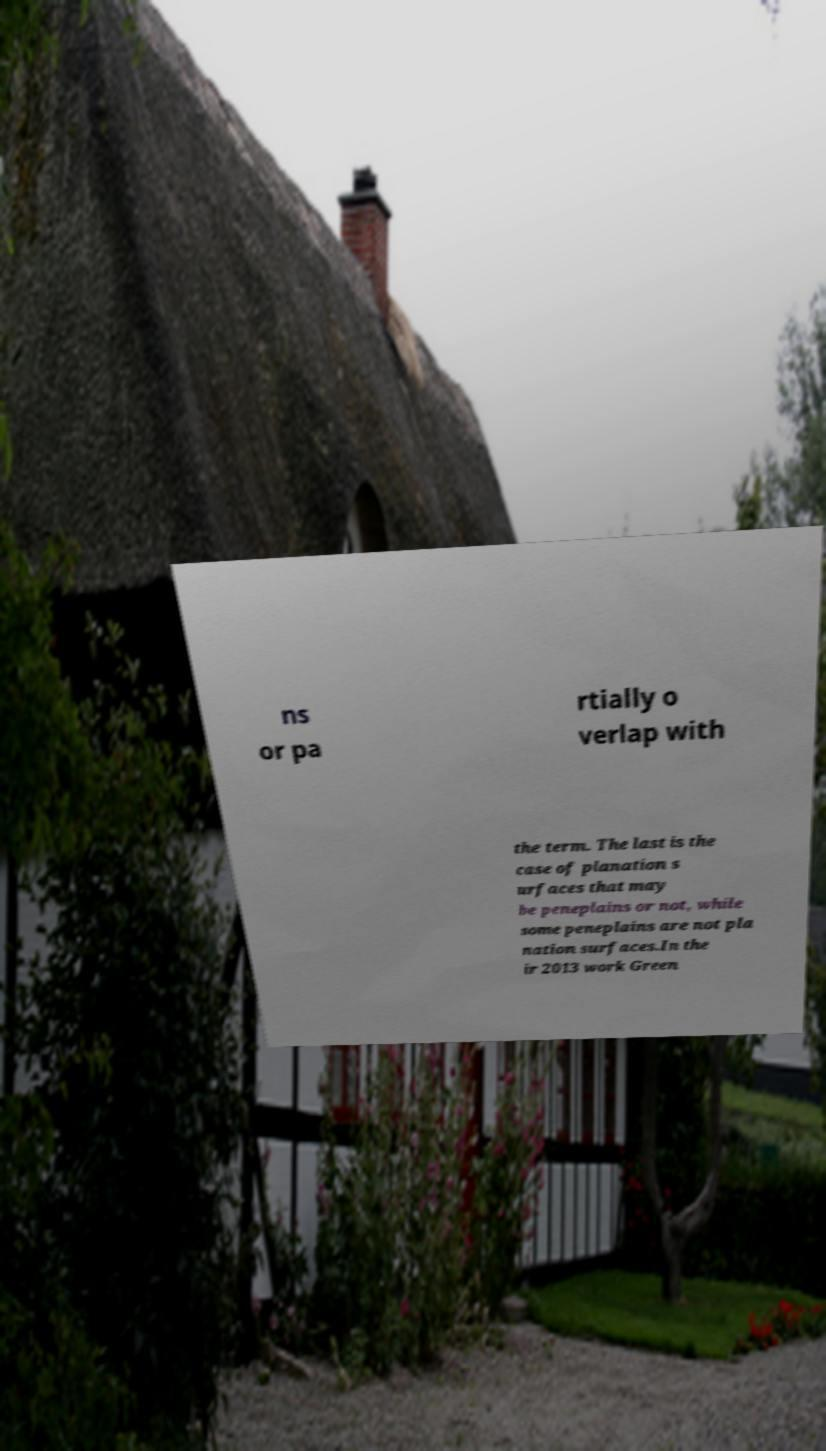I need the written content from this picture converted into text. Can you do that? ns or pa rtially o verlap with the term. The last is the case of planation s urfaces that may be peneplains or not, while some peneplains are not pla nation surfaces.In the ir 2013 work Green 